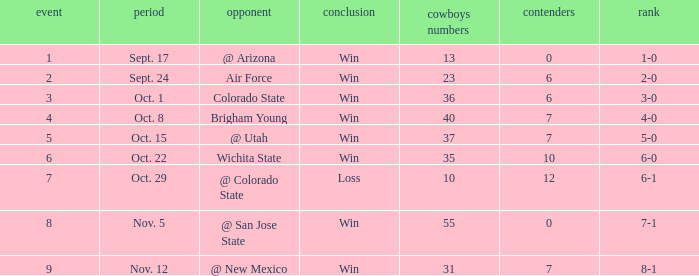What was the Cowboys' record for Nov. 5, 1966? 7-1. 